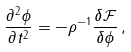Convert formula to latex. <formula><loc_0><loc_0><loc_500><loc_500>\frac { \partial ^ { 2 } \phi } { \partial t ^ { 2 } } = - \rho ^ { - 1 } \frac { \delta \mathcal { F } } { \delta \phi } \, ,</formula> 